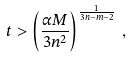Convert formula to latex. <formula><loc_0><loc_0><loc_500><loc_500>t > \left ( \frac { \alpha M } { 3 n ^ { 2 } } \right ) ^ { \frac { 1 } { 3 n - m - 2 } } \, ,</formula> 